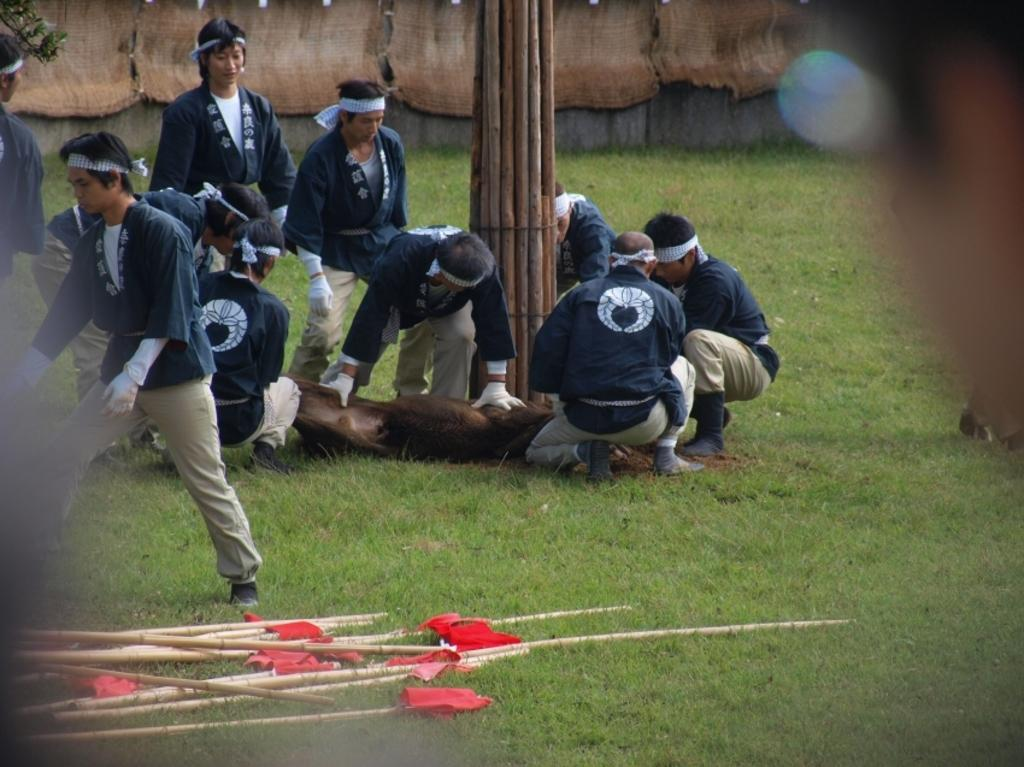What is the primary feature of the land in the image? The land in the image is covered with grass. What objects are placed on the grass? There are wooden sticks on the grass. What can be seen behind the wooden sticks? There is a group of people behind the wooden sticks. What are some of the people in the group doing? Some of the people in the group are doing work. What type of throat condition can be seen in the image? There is no throat condition present in the image. Are there any gloves visible in the image? There is no mention of gloves in the provided facts, so we cannot determine if any are visible in the image. 